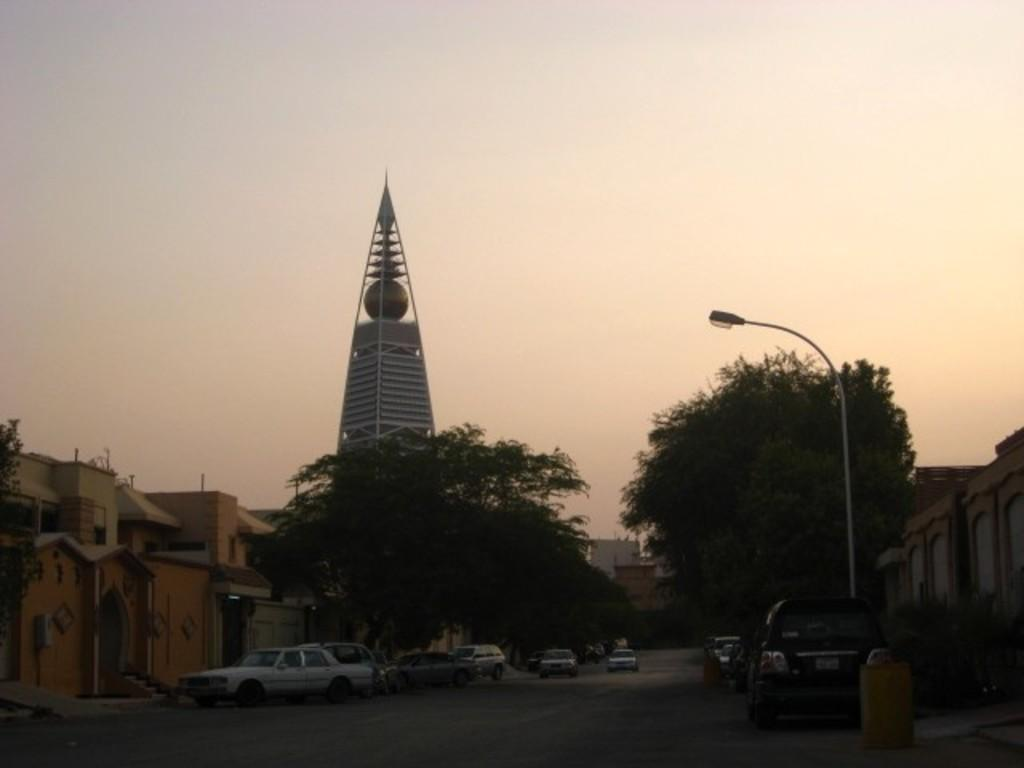What type of vehicles can be seen in the image? There are cars in the image. What natural elements are present in the image? There are trees in the image. What type of man-made structure is visible in the image? There is a street light in the image. What type of buildings can be seen in the image? There are buildings in the image. What is the primary feature of the foreground in the image? The foreground of the image consists of a road. Can you tell me how many judges are depicted in the image? There are no judges present in the image. What type of swing can be seen in the image? There is no swing present in the image. 